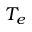Convert formula to latex. <formula><loc_0><loc_0><loc_500><loc_500>T _ { e }</formula> 